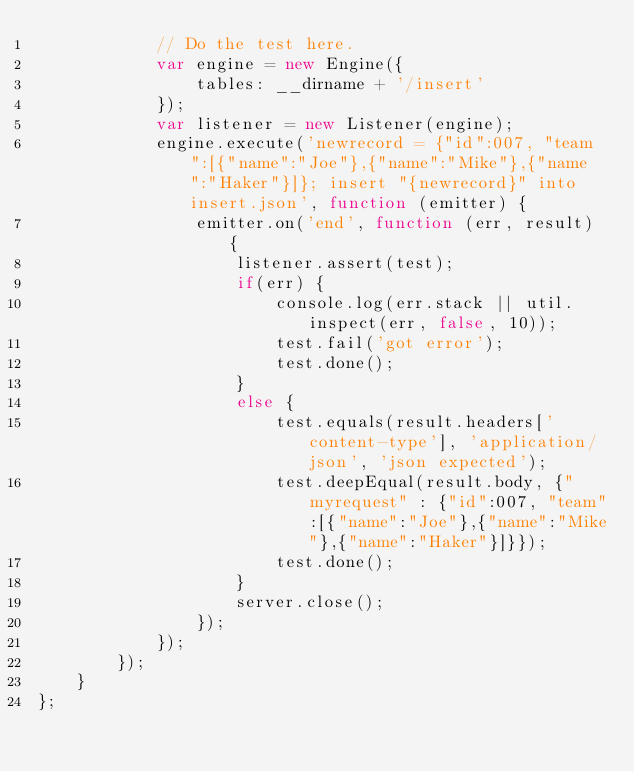<code> <loc_0><loc_0><loc_500><loc_500><_JavaScript_>            // Do the test here.
            var engine = new Engine({
                tables: __dirname + '/insert'
            });
            var listener = new Listener(engine);
            engine.execute('newrecord = {"id":007, "team":[{"name":"Joe"},{"name":"Mike"},{"name":"Haker"}]}; insert "{newrecord}" into insert.json', function (emitter) {
                emitter.on('end', function (err, result) {
                    listener.assert(test);
                    if(err) {
                        console.log(err.stack || util.inspect(err, false, 10));
                        test.fail('got error');
                        test.done();
                    }
                    else {
                        test.equals(result.headers['content-type'], 'application/json', 'json expected');
                        test.deepEqual(result.body, {"myrequest" : {"id":007, "team":[{"name":"Joe"},{"name":"Mike"},{"name":"Haker"}]}});
                        test.done();
                    }
                    server.close();
                });
            });
        });
    }
};</code> 